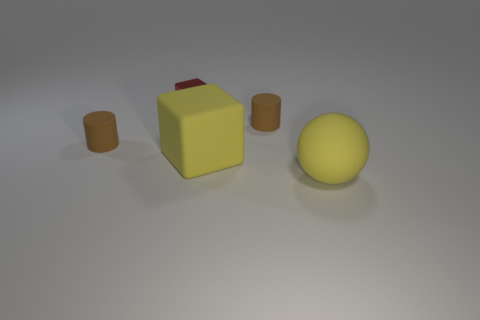Is there a brown cylinder?
Offer a terse response. Yes. The big yellow thing that is made of the same material as the big yellow ball is what shape?
Keep it short and to the point. Cube. What is the material of the red thing to the left of the big yellow sphere?
Offer a very short reply. Metal. There is a large matte object that is in front of the large block; is it the same color as the rubber block?
Offer a very short reply. Yes. What size is the brown thing that is to the right of the cylinder on the left side of the metal cube?
Make the answer very short. Small. Are there more brown things on the left side of the small red block than blue matte objects?
Offer a very short reply. Yes. Does the yellow matte object that is behind the yellow sphere have the same size as the large ball?
Offer a very short reply. Yes. The thing that is both to the right of the tiny metallic block and behind the yellow block is what color?
Provide a short and direct response. Brown. The yellow object that is the same size as the yellow block is what shape?
Ensure brevity in your answer.  Sphere. Are there any large rubber cubes of the same color as the sphere?
Make the answer very short. Yes. 